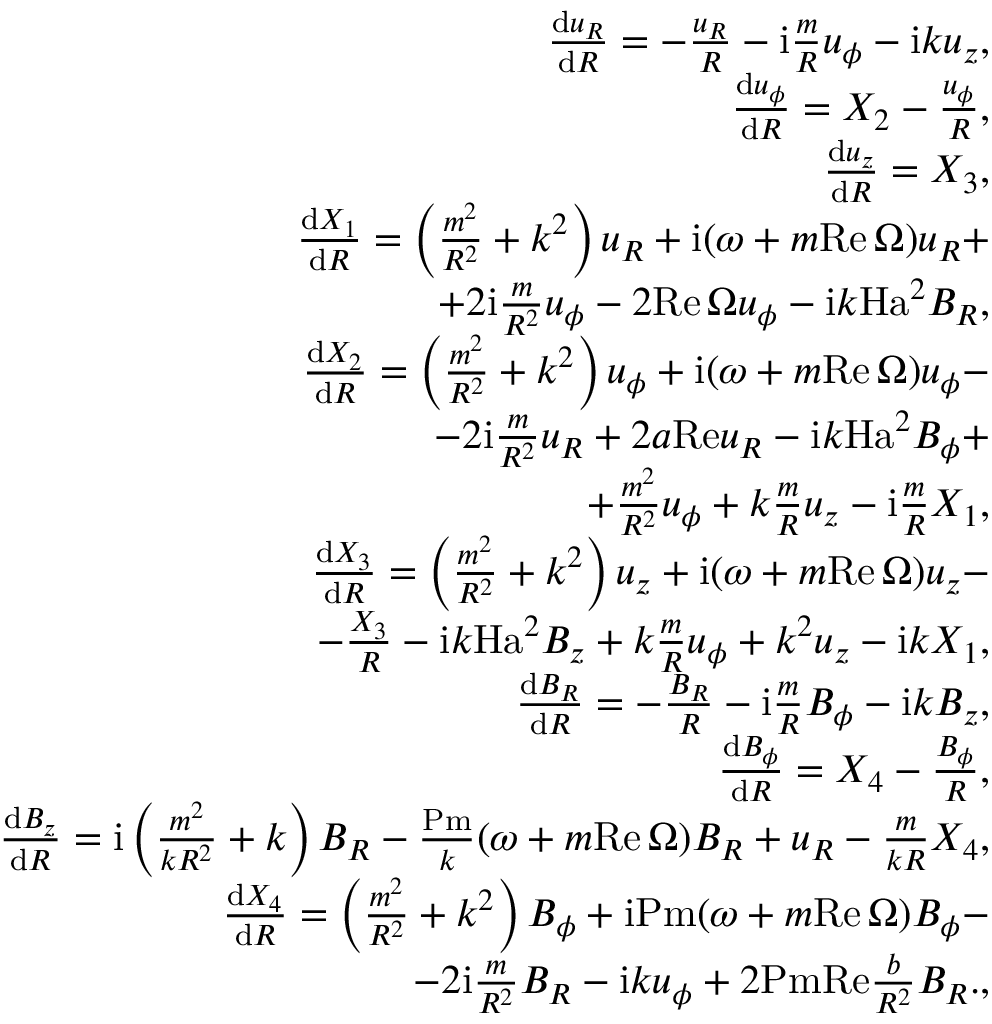<formula> <loc_0><loc_0><loc_500><loc_500>\begin{array} { r l r } & { \frac { d u _ { R } } { d R } = - \frac { u _ { R } } { R } - i \frac { m } { R } u _ { \phi } - { i } k u _ { z } , } \\ & { \frac { d u _ { \phi } } { d R } = X _ { 2 } - \frac { u _ { \phi } } { R } , } \\ & { \frac { d u _ { z } } { d R } = X _ { 3 } , } \\ & { \frac { d X _ { 1 } } { d R } = \left ( \frac { m ^ { 2 } } { R ^ { 2 } } + k ^ { 2 } \right ) u _ { R } + i ( \omega + m { R e } \, \Omega ) u _ { R } + } \\ & { \quad + 2 { i } \frac { m } { R ^ { 2 } } u _ { \phi } - 2 { R e } \, \Omega u _ { \phi } - { i } k { H a } ^ { 2 } B _ { R } , } \\ & { \frac { d X _ { 2 } } { d R } = \left ( \frac { m ^ { 2 } } { R ^ { 2 } } + k ^ { 2 } \right ) u _ { \phi } + { i } ( \omega + m { R e } \, \Omega ) u _ { \phi } - } \\ & { \quad - 2 { i } \frac { m } { R ^ { 2 } } u _ { R } + 2 a { R e } u _ { R } - { i } k H a ^ { 2 } B _ { \phi } + } \\ & { \quad + \frac { m ^ { 2 } } { R ^ { 2 } } u _ { \phi } + k \frac { m } { R } u _ { z } - { i } \frac { m } { R } X _ { 1 } , } \\ & { \frac { d X _ { 3 } } { d R } = \left ( \frac { m ^ { 2 } } { R ^ { 2 } } + k ^ { 2 } \right ) u _ { z } + { i } ( \omega + m R e \, \Omega ) u _ { z } - } \\ & { \quad - \frac { X _ { 3 } } { R } - i k { H a } ^ { 2 } B _ { z } + k \frac { m } { R } u _ { \phi } + k ^ { 2 } u _ { z } - { i } k X _ { 1 } , } \\ & { \frac { d B _ { R } } { d R } = - \frac { B _ { R } } { R } - i \frac { m } { R } B _ { \phi } - i k B _ { z } , } \\ & { \frac { d B _ { \phi } } { d R } = X _ { 4 } - \frac { B _ { \phi } } { R } , } \\ & { \frac { d B _ { z } } { d R } = { i } \left ( \frac { m ^ { 2 } } { k R ^ { 2 } } + k \right ) B _ { R } - \frac { P m } { k } ( \omega + m R e \, \Omega ) B _ { R } + u _ { R } - \frac { m } { k R } X _ { 4 } , } \\ & { \frac { d X _ { 4 } } { d R } = \left ( \frac { m ^ { 2 } } { R ^ { 2 } } + k ^ { 2 } \right ) B _ { \phi } + i P m ( \omega + m R e \, \Omega ) B _ { \phi } - } \\ & { \quad - 2 { i } \frac { m } { R ^ { 2 } } B _ { R } - i k u _ { \phi } + 2 P m R e \frac { b } { R ^ { 2 } } B _ { R } . , } \end{array}</formula> 